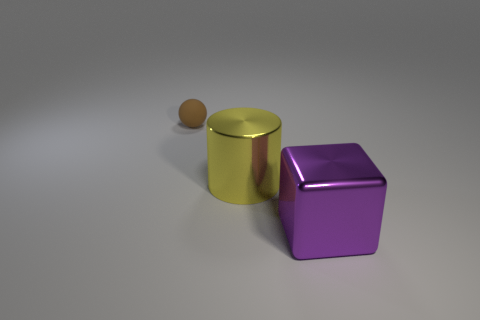Add 2 small things. How many objects exist? 5 Subtract all balls. How many objects are left? 2 Add 1 big shiny blocks. How many big shiny blocks are left? 2 Add 2 small yellow cylinders. How many small yellow cylinders exist? 2 Subtract 0 green cylinders. How many objects are left? 3 Subtract all small yellow spheres. Subtract all purple metal blocks. How many objects are left? 2 